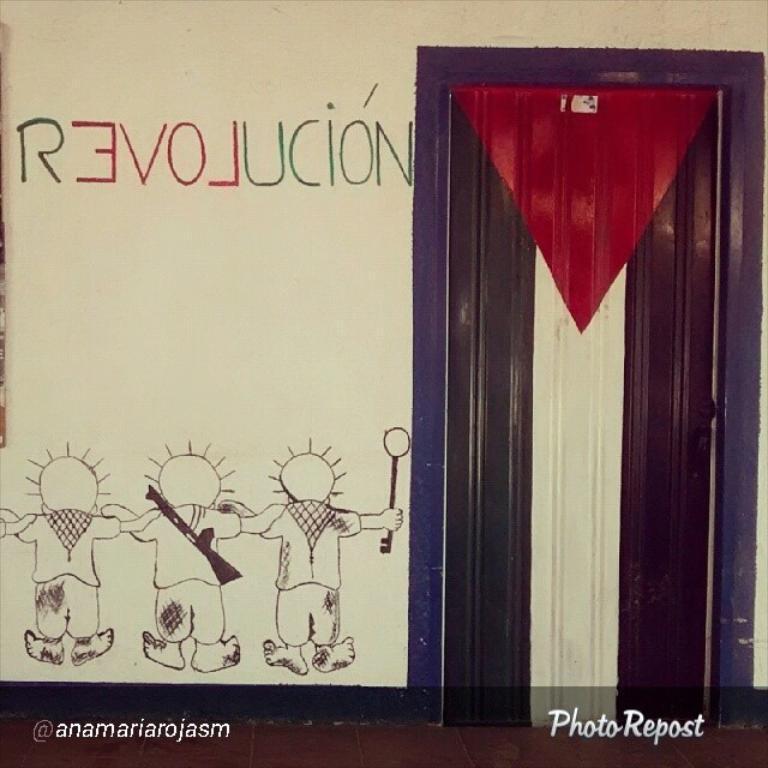Could you give a brief overview of what you see in this image? This picture is consists of a poster, which includes a door and toys on it. 